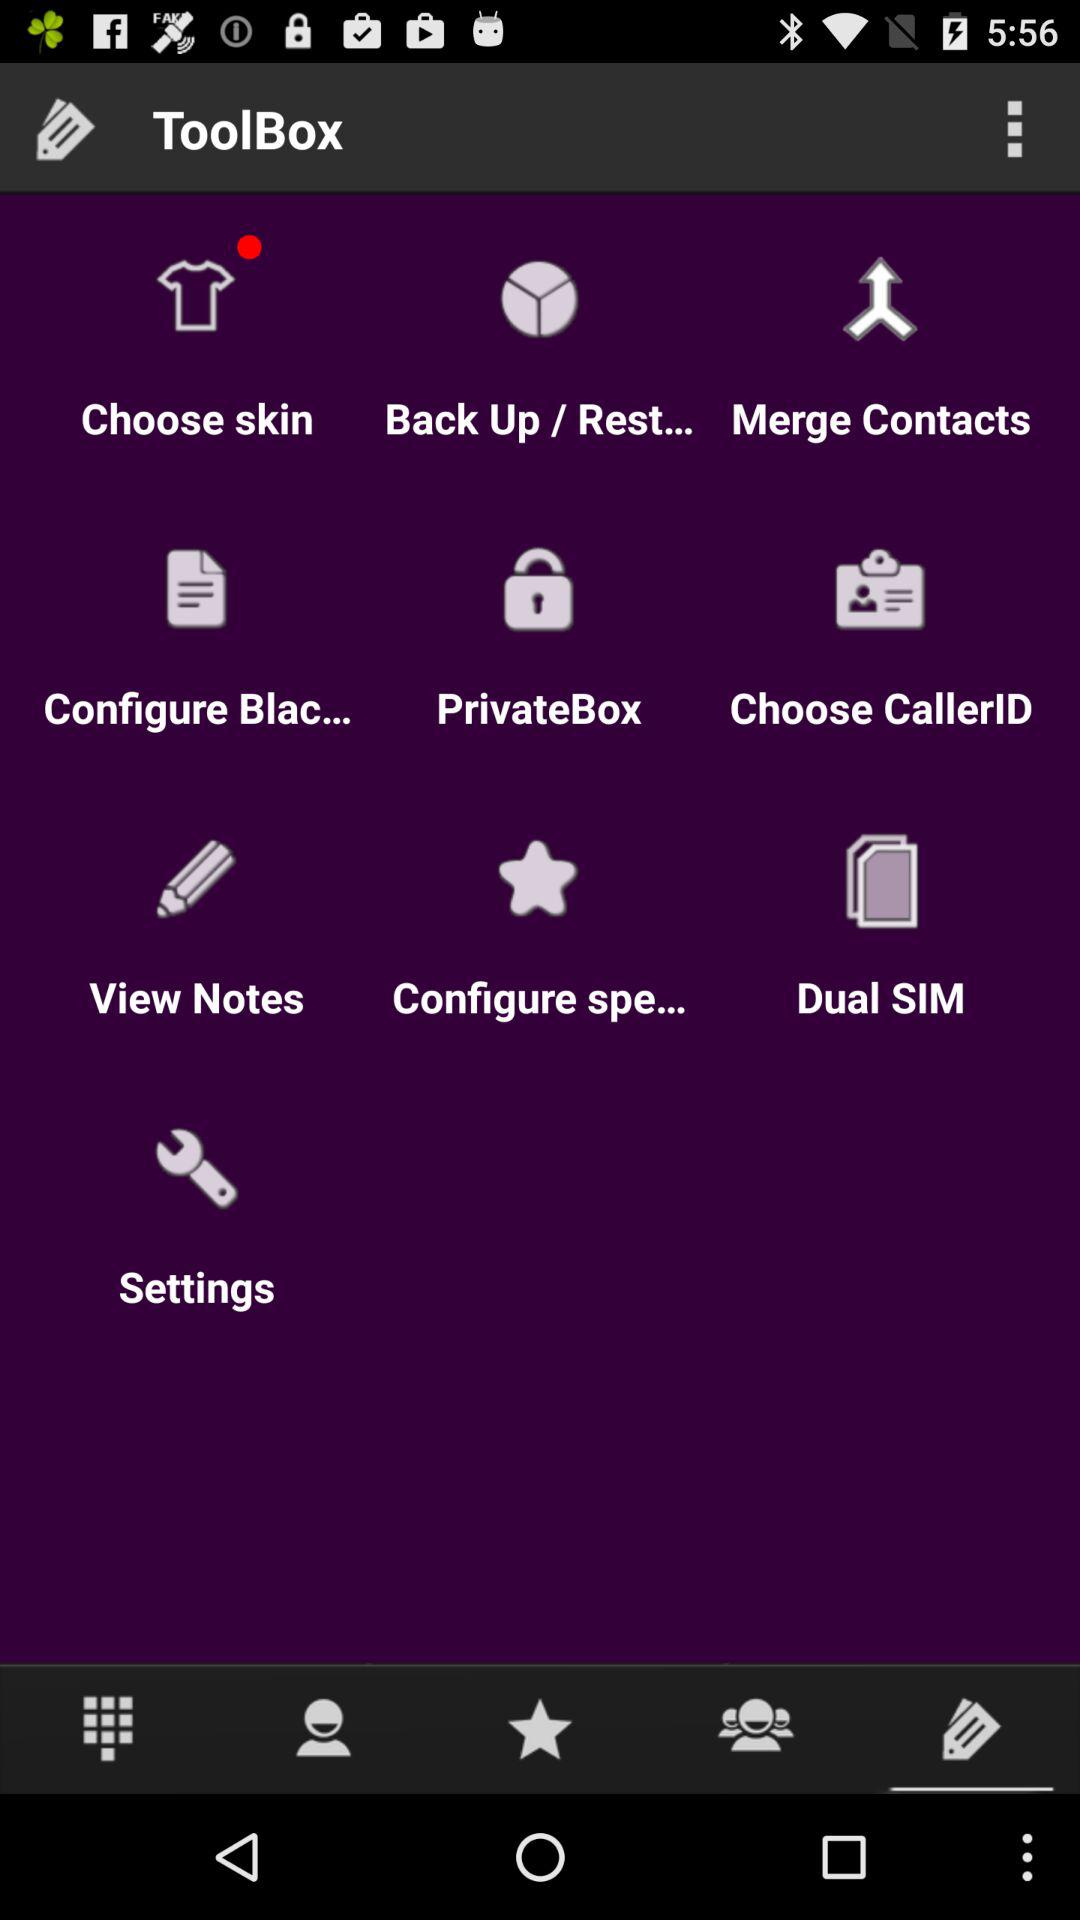How many of the items have a red circle on a purple background?
Answer the question using a single word or phrase. 1 